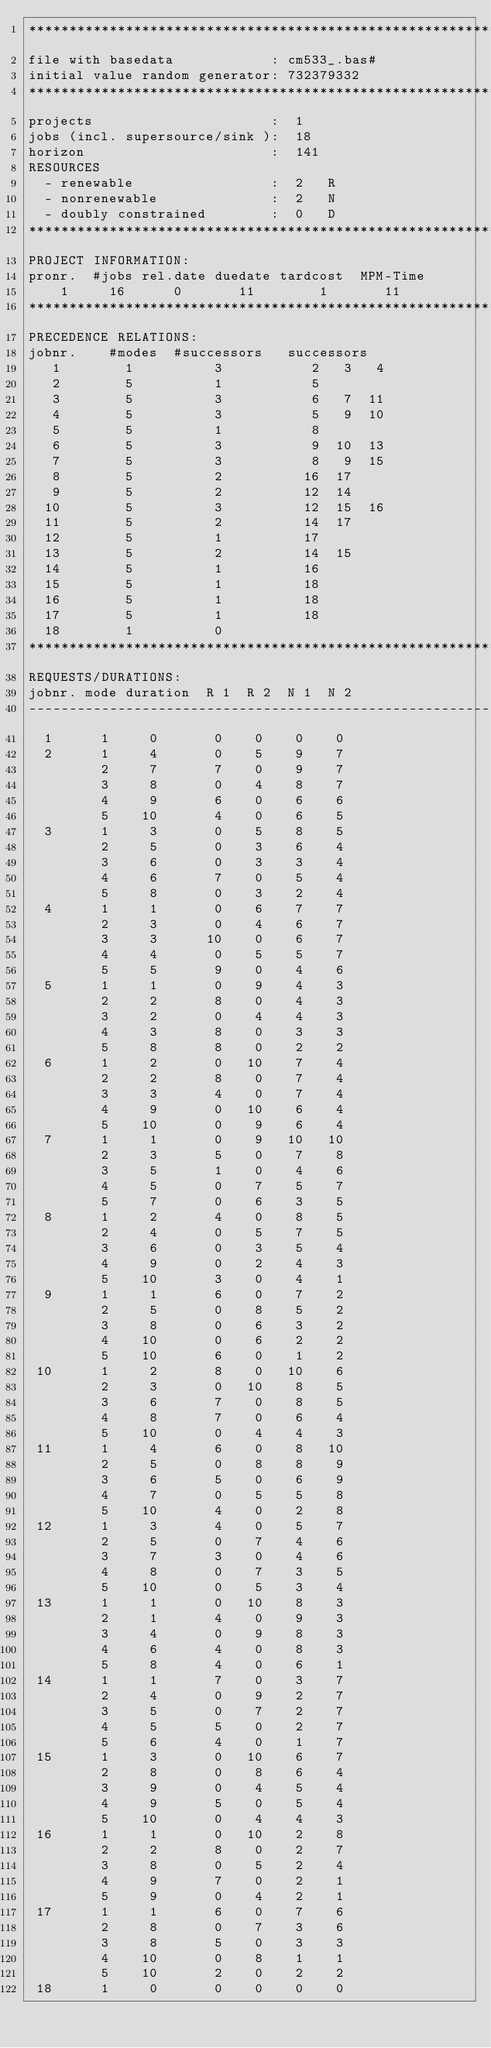Convert code to text. <code><loc_0><loc_0><loc_500><loc_500><_ObjectiveC_>************************************************************************
file with basedata            : cm533_.bas#
initial value random generator: 732379332
************************************************************************
projects                      :  1
jobs (incl. supersource/sink ):  18
horizon                       :  141
RESOURCES
  - renewable                 :  2   R
  - nonrenewable              :  2   N
  - doubly constrained        :  0   D
************************************************************************
PROJECT INFORMATION:
pronr.  #jobs rel.date duedate tardcost  MPM-Time
    1     16      0       11        1       11
************************************************************************
PRECEDENCE RELATIONS:
jobnr.    #modes  #successors   successors
   1        1          3           2   3   4
   2        5          1           5
   3        5          3           6   7  11
   4        5          3           5   9  10
   5        5          1           8
   6        5          3           9  10  13
   7        5          3           8   9  15
   8        5          2          16  17
   9        5          2          12  14
  10        5          3          12  15  16
  11        5          2          14  17
  12        5          1          17
  13        5          2          14  15
  14        5          1          16
  15        5          1          18
  16        5          1          18
  17        5          1          18
  18        1          0        
************************************************************************
REQUESTS/DURATIONS:
jobnr. mode duration  R 1  R 2  N 1  N 2
------------------------------------------------------------------------
  1      1     0       0    0    0    0
  2      1     4       0    5    9    7
         2     7       7    0    9    7
         3     8       0    4    8    7
         4     9       6    0    6    6
         5    10       4    0    6    5
  3      1     3       0    5    8    5
         2     5       0    3    6    4
         3     6       0    3    3    4
         4     6       7    0    5    4
         5     8       0    3    2    4
  4      1     1       0    6    7    7
         2     3       0    4    6    7
         3     3      10    0    6    7
         4     4       0    5    5    7
         5     5       9    0    4    6
  5      1     1       0    9    4    3
         2     2       8    0    4    3
         3     2       0    4    4    3
         4     3       8    0    3    3
         5     8       8    0    2    2
  6      1     2       0   10    7    4
         2     2       8    0    7    4
         3     3       4    0    7    4
         4     9       0   10    6    4
         5    10       0    9    6    4
  7      1     1       0    9   10   10
         2     3       5    0    7    8
         3     5       1    0    4    6
         4     5       0    7    5    7
         5     7       0    6    3    5
  8      1     2       4    0    8    5
         2     4       0    5    7    5
         3     6       0    3    5    4
         4     9       0    2    4    3
         5    10       3    0    4    1
  9      1     1       6    0    7    2
         2     5       0    8    5    2
         3     8       0    6    3    2
         4    10       0    6    2    2
         5    10       6    0    1    2
 10      1     2       8    0   10    6
         2     3       0   10    8    5
         3     6       7    0    8    5
         4     8       7    0    6    4
         5    10       0    4    4    3
 11      1     4       6    0    8   10
         2     5       0    8    8    9
         3     6       5    0    6    9
         4     7       0    5    5    8
         5    10       4    0    2    8
 12      1     3       4    0    5    7
         2     5       0    7    4    6
         3     7       3    0    4    6
         4     8       0    7    3    5
         5    10       0    5    3    4
 13      1     1       0   10    8    3
         2     1       4    0    9    3
         3     4       0    9    8    3
         4     6       4    0    8    3
         5     8       4    0    6    1
 14      1     1       7    0    3    7
         2     4       0    9    2    7
         3     5       0    7    2    7
         4     5       5    0    2    7
         5     6       4    0    1    7
 15      1     3       0   10    6    7
         2     8       0    8    6    4
         3     9       0    4    5    4
         4     9       5    0    5    4
         5    10       0    4    4    3
 16      1     1       0   10    2    8
         2     2       8    0    2    7
         3     8       0    5    2    4
         4     9       7    0    2    1
         5     9       0    4    2    1
 17      1     1       6    0    7    6
         2     8       0    7    3    6
         3     8       5    0    3    3
         4    10       0    8    1    1
         5    10       2    0    2    2
 18      1     0       0    0    0    0</code> 